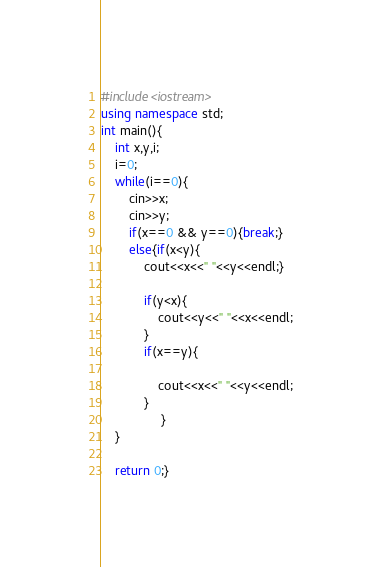<code> <loc_0><loc_0><loc_500><loc_500><_C++_>#include<iostream>
using namespace std;
int main(){
    int x,y,i;
    i=0;
    while(i==0){
        cin>>x;
        cin>>y;
        if(x==0 && y==0){break;}
        else{if(x<y){
            cout<<x<<" "<<y<<endl;}
        
            if(y<x){
                cout<<y<<" "<<x<<endl;
            }
            if(x==y){
                
                cout<<x<<" "<<y<<endl;
            }
                 }
    }

    return 0;}</code> 